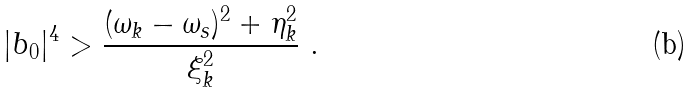<formula> <loc_0><loc_0><loc_500><loc_500>| b _ { 0 } | ^ { 4 } > \frac { ( \omega _ { k } - \omega _ { s } ) ^ { 2 } + \eta _ { k } ^ { 2 } } { \xi _ { k } ^ { 2 } } \ .</formula> 